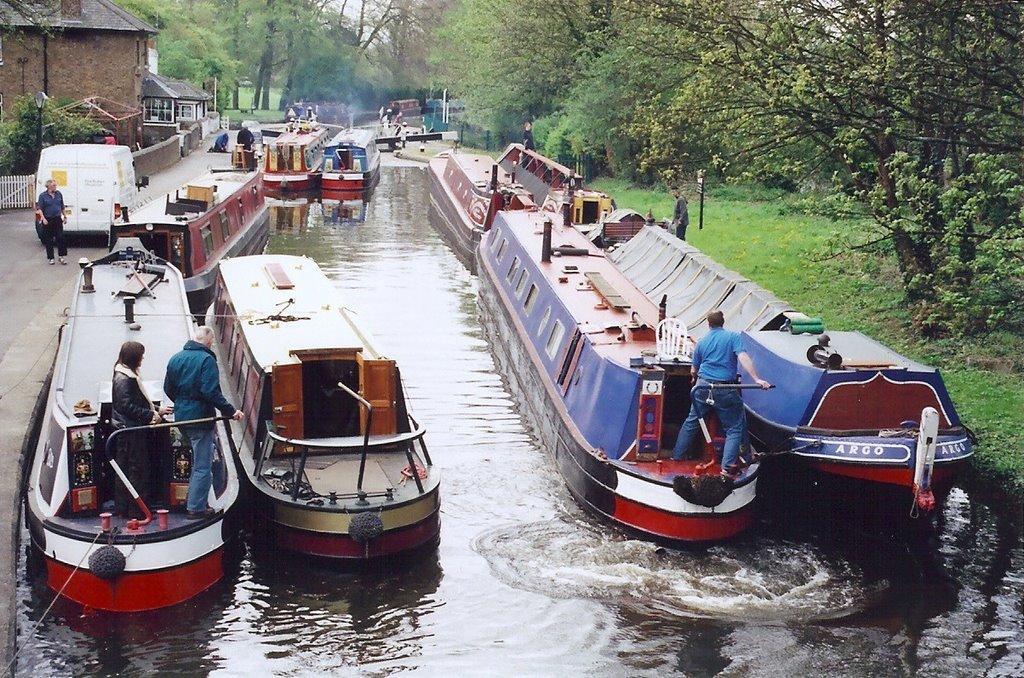Please provide a concise description of this image. In this image I can see few boats on the water. I can see few trees. I can see a building. I can see few persons. I can see a vehicle. 